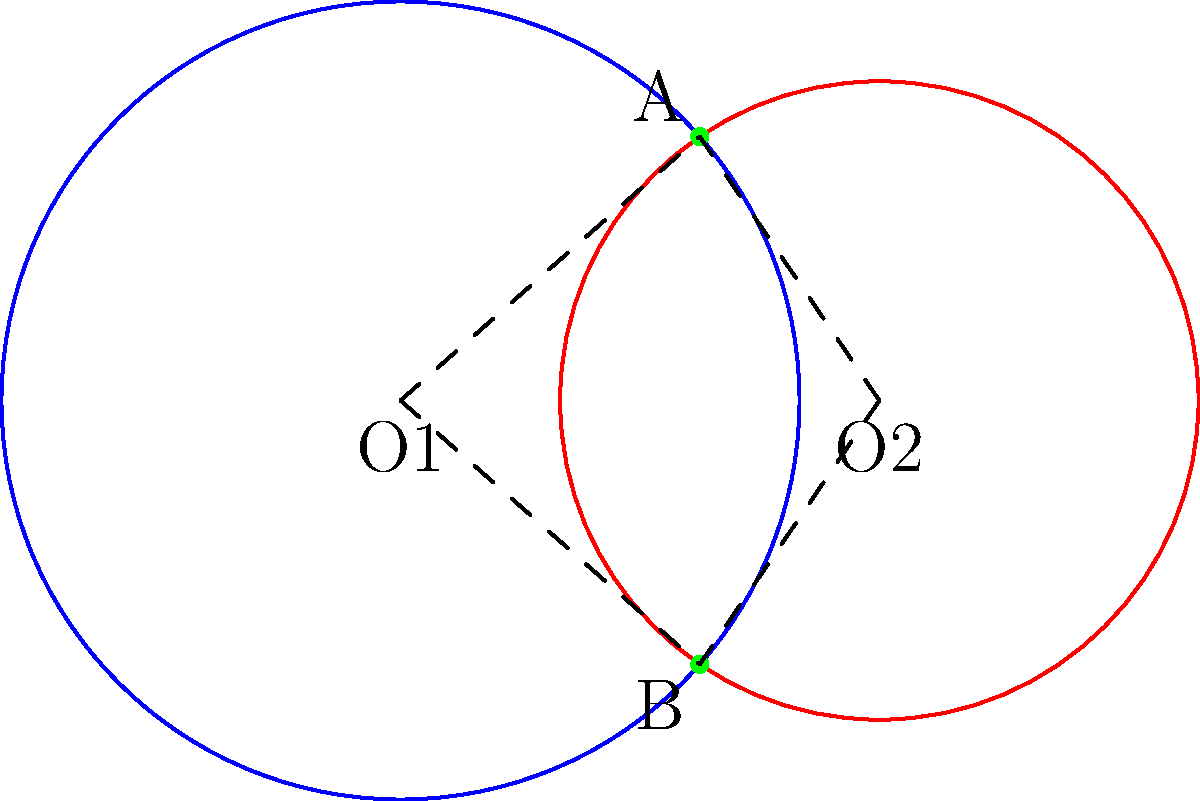In the diagram, two circles represent the visual fields of a patient's left and right eyes. The circles intersect at points A and B. If the centers of the circles (O1 and O2) are 3 units apart, the radius of the left eye's visual field (O1) is 2.5 units, and the radius of the right eye's visual field (O2) is 2 units, what is the area of the overlapping region (in square units)? To find the area of the overlapping region, we need to follow these steps:

1) First, we need to find the angle subtended by the chord AB at the center of each circle. Let's call these angles $\theta_1$ and $\theta_2$ for O1 and O2 respectively.

2) We can find these angles using the cosine law:
   
   For O1: $\cos(\frac{\theta_1}{2}) = \frac{3}{2(2.5)} = 0.6$
   For O2: $\cos(\frac{\theta_2}{2}) = \frac{3}{2(2)} = 0.75$

3) Taking the inverse cosine:
   
   $\frac{\theta_1}{2} = \arccos(0.6) \approx 0.9273$ radians
   $\frac{\theta_2}{2} = \arccos(0.75) \approx 0.7227$ radians

4) The area of a sector is given by $\frac{1}{2}r^2\theta$. The area of the triangle formed by the center and the chord is $\frac{1}{2}r^2\sin(\theta)$.

5) The area of the lens-shaped overlap is the sum of the two sectors minus the two triangles:

   Area = $\frac{1}{2}(2.5)^2(2(0.9273)) + \frac{1}{2}(2)^2(2(0.7227)) - \frac{1}{2}(2.5)^2\sin(2(0.9273)) - \frac{1}{2}(2)^2\sin(2(0.7227))$

6) Calculating this:
   
   Area $\approx 2.8977 + 1.4454 - 2.2582 - 1.1598 \approx 0.9251$ square units
Answer: $0.9251$ square units 